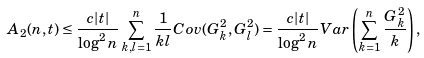Convert formula to latex. <formula><loc_0><loc_0><loc_500><loc_500>A _ { 2 } ( n , t ) & \leq \frac { c | t | } { \log ^ { 2 } n } \sum _ { k , l = 1 } ^ { n } \frac { 1 } { k l } { C o v } ( G ^ { 2 } _ { k } , G ^ { 2 } _ { l } ) = \frac { c | t | } { \log ^ { 2 } n } { V a r } \left ( \sum _ { k = 1 } ^ { n } \frac { G ^ { 2 } _ { k } } { k } \right ) ,</formula> 